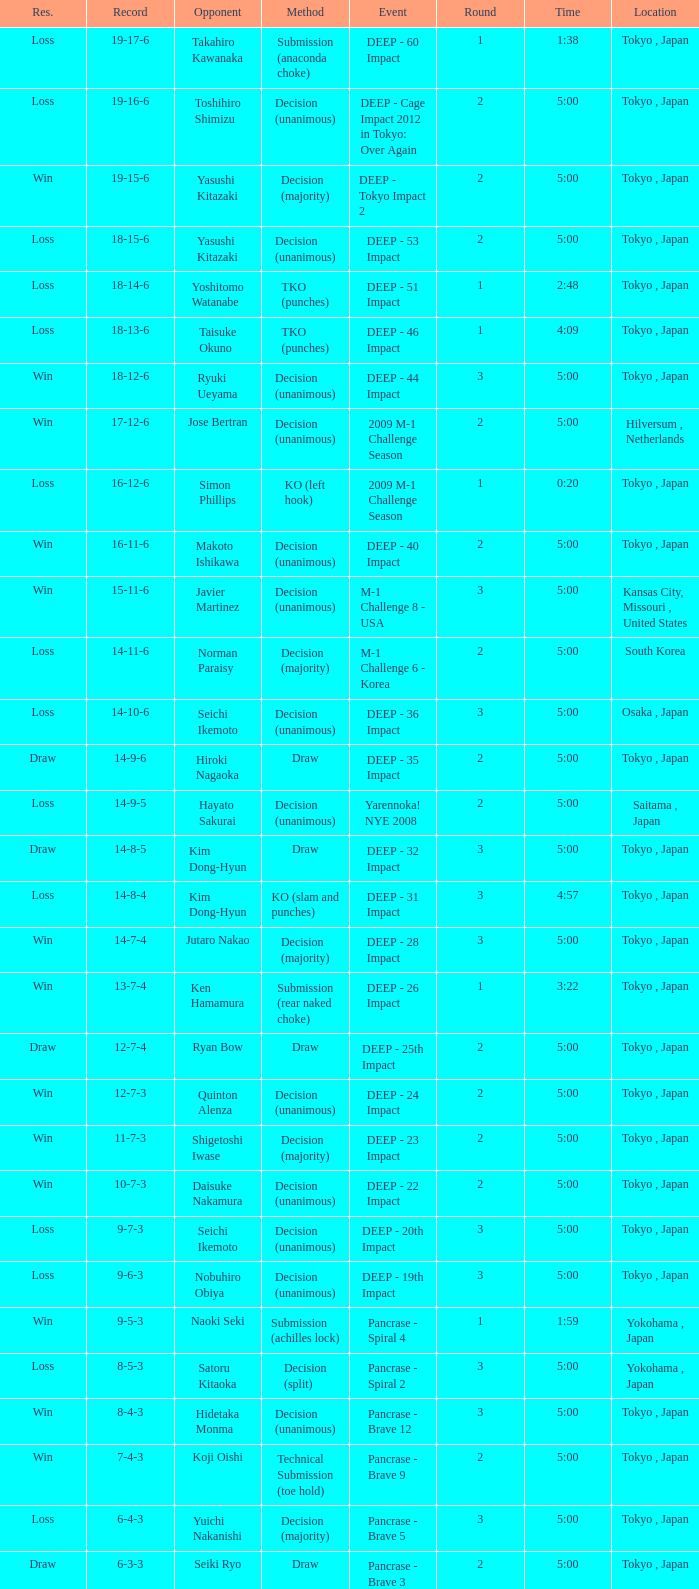What is the location when the record is 5-1-1? Osaka , Japan. 